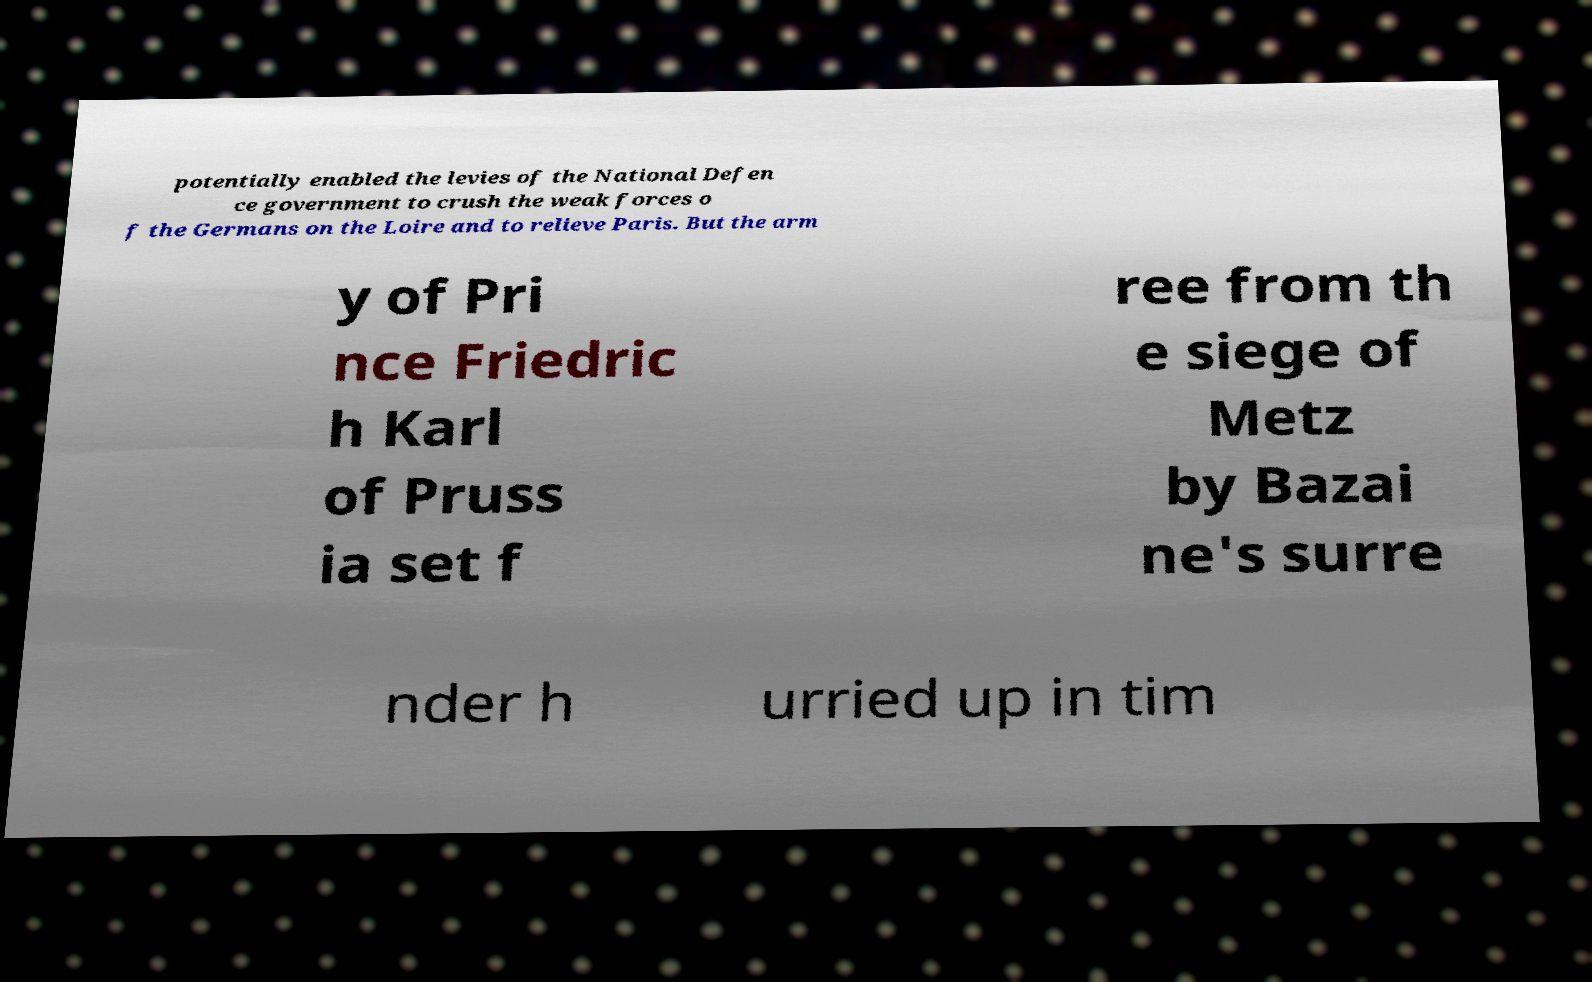Please read and relay the text visible in this image. What does it say? potentially enabled the levies of the National Defen ce government to crush the weak forces o f the Germans on the Loire and to relieve Paris. But the arm y of Pri nce Friedric h Karl of Pruss ia set f ree from th e siege of Metz by Bazai ne's surre nder h urried up in tim 